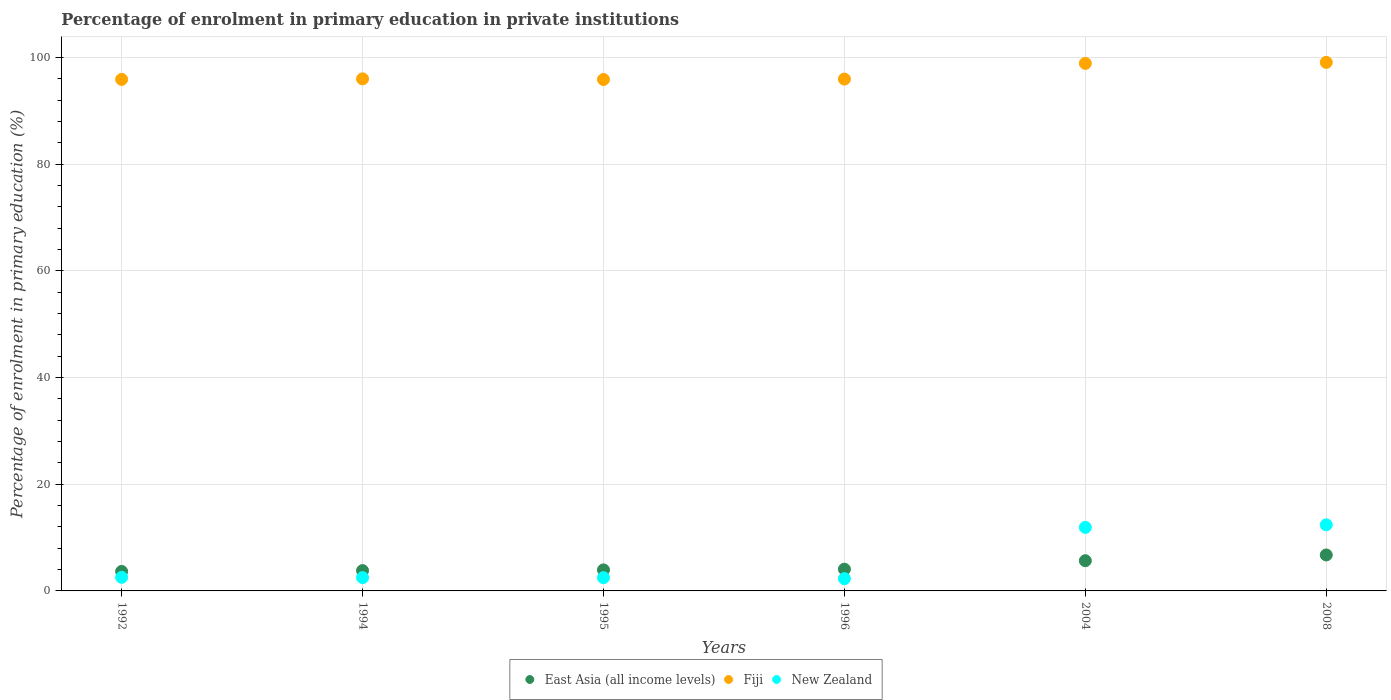How many different coloured dotlines are there?
Make the answer very short. 3. What is the percentage of enrolment in primary education in New Zealand in 1994?
Your answer should be very brief. 2.49. Across all years, what is the maximum percentage of enrolment in primary education in New Zealand?
Offer a very short reply. 12.39. Across all years, what is the minimum percentage of enrolment in primary education in East Asia (all income levels)?
Your answer should be compact. 3.65. In which year was the percentage of enrolment in primary education in Fiji maximum?
Make the answer very short. 2008. What is the total percentage of enrolment in primary education in New Zealand in the graph?
Make the answer very short. 34.14. What is the difference between the percentage of enrolment in primary education in New Zealand in 1994 and that in 1995?
Ensure brevity in your answer.  0.01. What is the difference between the percentage of enrolment in primary education in East Asia (all income levels) in 2004 and the percentage of enrolment in primary education in Fiji in 1996?
Ensure brevity in your answer.  -90.29. What is the average percentage of enrolment in primary education in East Asia (all income levels) per year?
Your response must be concise. 4.65. In the year 1994, what is the difference between the percentage of enrolment in primary education in New Zealand and percentage of enrolment in primary education in Fiji?
Provide a succinct answer. -93.5. In how many years, is the percentage of enrolment in primary education in New Zealand greater than 72 %?
Ensure brevity in your answer.  0. What is the ratio of the percentage of enrolment in primary education in East Asia (all income levels) in 1994 to that in 1995?
Ensure brevity in your answer.  0.97. Is the percentage of enrolment in primary education in Fiji in 2004 less than that in 2008?
Give a very brief answer. Yes. What is the difference between the highest and the second highest percentage of enrolment in primary education in Fiji?
Provide a short and direct response. 0.19. What is the difference between the highest and the lowest percentage of enrolment in primary education in New Zealand?
Give a very brief answer. 10.09. In how many years, is the percentage of enrolment in primary education in Fiji greater than the average percentage of enrolment in primary education in Fiji taken over all years?
Ensure brevity in your answer.  2. Is it the case that in every year, the sum of the percentage of enrolment in primary education in New Zealand and percentage of enrolment in primary education in East Asia (all income levels)  is greater than the percentage of enrolment in primary education in Fiji?
Provide a short and direct response. No. Does the percentage of enrolment in primary education in New Zealand monotonically increase over the years?
Offer a very short reply. No. Is the percentage of enrolment in primary education in Fiji strictly greater than the percentage of enrolment in primary education in New Zealand over the years?
Offer a terse response. Yes. Is the percentage of enrolment in primary education in New Zealand strictly less than the percentage of enrolment in primary education in Fiji over the years?
Ensure brevity in your answer.  Yes. How many dotlines are there?
Provide a succinct answer. 3. Where does the legend appear in the graph?
Keep it short and to the point. Bottom center. How many legend labels are there?
Keep it short and to the point. 3. What is the title of the graph?
Ensure brevity in your answer.  Percentage of enrolment in primary education in private institutions. What is the label or title of the X-axis?
Provide a short and direct response. Years. What is the label or title of the Y-axis?
Ensure brevity in your answer.  Percentage of enrolment in primary education (%). What is the Percentage of enrolment in primary education (%) in East Asia (all income levels) in 1992?
Offer a very short reply. 3.65. What is the Percentage of enrolment in primary education (%) of Fiji in 1992?
Give a very brief answer. 95.9. What is the Percentage of enrolment in primary education (%) of New Zealand in 1992?
Keep it short and to the point. 2.55. What is the Percentage of enrolment in primary education (%) in East Asia (all income levels) in 1994?
Your answer should be compact. 3.81. What is the Percentage of enrolment in primary education (%) in Fiji in 1994?
Offer a very short reply. 96. What is the Percentage of enrolment in primary education (%) in New Zealand in 1994?
Ensure brevity in your answer.  2.49. What is the Percentage of enrolment in primary education (%) in East Asia (all income levels) in 1995?
Your answer should be compact. 3.94. What is the Percentage of enrolment in primary education (%) in Fiji in 1995?
Give a very brief answer. 95.88. What is the Percentage of enrolment in primary education (%) of New Zealand in 1995?
Your response must be concise. 2.48. What is the Percentage of enrolment in primary education (%) of East Asia (all income levels) in 1996?
Your answer should be very brief. 4.07. What is the Percentage of enrolment in primary education (%) of Fiji in 1996?
Give a very brief answer. 95.95. What is the Percentage of enrolment in primary education (%) of New Zealand in 1996?
Make the answer very short. 2.31. What is the Percentage of enrolment in primary education (%) of East Asia (all income levels) in 2004?
Provide a succinct answer. 5.66. What is the Percentage of enrolment in primary education (%) of Fiji in 2004?
Provide a succinct answer. 98.9. What is the Percentage of enrolment in primary education (%) of New Zealand in 2004?
Offer a very short reply. 11.91. What is the Percentage of enrolment in primary education (%) of East Asia (all income levels) in 2008?
Offer a terse response. 6.74. What is the Percentage of enrolment in primary education (%) in Fiji in 2008?
Offer a terse response. 99.08. What is the Percentage of enrolment in primary education (%) of New Zealand in 2008?
Your response must be concise. 12.39. Across all years, what is the maximum Percentage of enrolment in primary education (%) in East Asia (all income levels)?
Offer a very short reply. 6.74. Across all years, what is the maximum Percentage of enrolment in primary education (%) in Fiji?
Give a very brief answer. 99.08. Across all years, what is the maximum Percentage of enrolment in primary education (%) in New Zealand?
Keep it short and to the point. 12.39. Across all years, what is the minimum Percentage of enrolment in primary education (%) of East Asia (all income levels)?
Make the answer very short. 3.65. Across all years, what is the minimum Percentage of enrolment in primary education (%) of Fiji?
Your response must be concise. 95.88. Across all years, what is the minimum Percentage of enrolment in primary education (%) of New Zealand?
Your response must be concise. 2.31. What is the total Percentage of enrolment in primary education (%) of East Asia (all income levels) in the graph?
Your answer should be very brief. 27.88. What is the total Percentage of enrolment in primary education (%) in Fiji in the graph?
Ensure brevity in your answer.  581.7. What is the total Percentage of enrolment in primary education (%) in New Zealand in the graph?
Provide a short and direct response. 34.14. What is the difference between the Percentage of enrolment in primary education (%) in East Asia (all income levels) in 1992 and that in 1994?
Make the answer very short. -0.16. What is the difference between the Percentage of enrolment in primary education (%) of Fiji in 1992 and that in 1994?
Ensure brevity in your answer.  -0.1. What is the difference between the Percentage of enrolment in primary education (%) in New Zealand in 1992 and that in 1994?
Provide a succinct answer. 0.06. What is the difference between the Percentage of enrolment in primary education (%) in East Asia (all income levels) in 1992 and that in 1995?
Give a very brief answer. -0.29. What is the difference between the Percentage of enrolment in primary education (%) in Fiji in 1992 and that in 1995?
Provide a succinct answer. 0.02. What is the difference between the Percentage of enrolment in primary education (%) of New Zealand in 1992 and that in 1995?
Provide a succinct answer. 0.06. What is the difference between the Percentage of enrolment in primary education (%) in East Asia (all income levels) in 1992 and that in 1996?
Ensure brevity in your answer.  -0.42. What is the difference between the Percentage of enrolment in primary education (%) of Fiji in 1992 and that in 1996?
Keep it short and to the point. -0.06. What is the difference between the Percentage of enrolment in primary education (%) in New Zealand in 1992 and that in 1996?
Provide a succinct answer. 0.24. What is the difference between the Percentage of enrolment in primary education (%) in East Asia (all income levels) in 1992 and that in 2004?
Ensure brevity in your answer.  -2.01. What is the difference between the Percentage of enrolment in primary education (%) in Fiji in 1992 and that in 2004?
Make the answer very short. -3. What is the difference between the Percentage of enrolment in primary education (%) in New Zealand in 1992 and that in 2004?
Offer a terse response. -9.36. What is the difference between the Percentage of enrolment in primary education (%) of East Asia (all income levels) in 1992 and that in 2008?
Your response must be concise. -3.09. What is the difference between the Percentage of enrolment in primary education (%) in Fiji in 1992 and that in 2008?
Provide a succinct answer. -3.19. What is the difference between the Percentage of enrolment in primary education (%) in New Zealand in 1992 and that in 2008?
Offer a terse response. -9.85. What is the difference between the Percentage of enrolment in primary education (%) in East Asia (all income levels) in 1994 and that in 1995?
Offer a terse response. -0.13. What is the difference between the Percentage of enrolment in primary education (%) in Fiji in 1994 and that in 1995?
Provide a succinct answer. 0.12. What is the difference between the Percentage of enrolment in primary education (%) in New Zealand in 1994 and that in 1995?
Make the answer very short. 0.01. What is the difference between the Percentage of enrolment in primary education (%) of East Asia (all income levels) in 1994 and that in 1996?
Make the answer very short. -0.26. What is the difference between the Percentage of enrolment in primary education (%) in Fiji in 1994 and that in 1996?
Your answer should be compact. 0.04. What is the difference between the Percentage of enrolment in primary education (%) in New Zealand in 1994 and that in 1996?
Provide a short and direct response. 0.19. What is the difference between the Percentage of enrolment in primary education (%) of East Asia (all income levels) in 1994 and that in 2004?
Provide a succinct answer. -1.85. What is the difference between the Percentage of enrolment in primary education (%) in Fiji in 1994 and that in 2004?
Offer a very short reply. -2.9. What is the difference between the Percentage of enrolment in primary education (%) of New Zealand in 1994 and that in 2004?
Make the answer very short. -9.42. What is the difference between the Percentage of enrolment in primary education (%) in East Asia (all income levels) in 1994 and that in 2008?
Provide a succinct answer. -2.93. What is the difference between the Percentage of enrolment in primary education (%) in Fiji in 1994 and that in 2008?
Provide a succinct answer. -3.09. What is the difference between the Percentage of enrolment in primary education (%) in New Zealand in 1994 and that in 2008?
Keep it short and to the point. -9.9. What is the difference between the Percentage of enrolment in primary education (%) in East Asia (all income levels) in 1995 and that in 1996?
Offer a terse response. -0.13. What is the difference between the Percentage of enrolment in primary education (%) in Fiji in 1995 and that in 1996?
Your answer should be compact. -0.08. What is the difference between the Percentage of enrolment in primary education (%) of New Zealand in 1995 and that in 1996?
Provide a succinct answer. 0.18. What is the difference between the Percentage of enrolment in primary education (%) in East Asia (all income levels) in 1995 and that in 2004?
Offer a very short reply. -1.72. What is the difference between the Percentage of enrolment in primary education (%) of Fiji in 1995 and that in 2004?
Your response must be concise. -3.02. What is the difference between the Percentage of enrolment in primary education (%) in New Zealand in 1995 and that in 2004?
Offer a very short reply. -9.43. What is the difference between the Percentage of enrolment in primary education (%) of East Asia (all income levels) in 1995 and that in 2008?
Ensure brevity in your answer.  -2.8. What is the difference between the Percentage of enrolment in primary education (%) of Fiji in 1995 and that in 2008?
Provide a succinct answer. -3.21. What is the difference between the Percentage of enrolment in primary education (%) of New Zealand in 1995 and that in 2008?
Ensure brevity in your answer.  -9.91. What is the difference between the Percentage of enrolment in primary education (%) in East Asia (all income levels) in 1996 and that in 2004?
Offer a terse response. -1.59. What is the difference between the Percentage of enrolment in primary education (%) in Fiji in 1996 and that in 2004?
Make the answer very short. -2.94. What is the difference between the Percentage of enrolment in primary education (%) in New Zealand in 1996 and that in 2004?
Provide a succinct answer. -9.6. What is the difference between the Percentage of enrolment in primary education (%) in East Asia (all income levels) in 1996 and that in 2008?
Make the answer very short. -2.67. What is the difference between the Percentage of enrolment in primary education (%) of Fiji in 1996 and that in 2008?
Provide a succinct answer. -3.13. What is the difference between the Percentage of enrolment in primary education (%) of New Zealand in 1996 and that in 2008?
Your answer should be compact. -10.09. What is the difference between the Percentage of enrolment in primary education (%) in East Asia (all income levels) in 2004 and that in 2008?
Give a very brief answer. -1.08. What is the difference between the Percentage of enrolment in primary education (%) in Fiji in 2004 and that in 2008?
Provide a succinct answer. -0.19. What is the difference between the Percentage of enrolment in primary education (%) in New Zealand in 2004 and that in 2008?
Offer a terse response. -0.48. What is the difference between the Percentage of enrolment in primary education (%) of East Asia (all income levels) in 1992 and the Percentage of enrolment in primary education (%) of Fiji in 1994?
Provide a short and direct response. -92.34. What is the difference between the Percentage of enrolment in primary education (%) of East Asia (all income levels) in 1992 and the Percentage of enrolment in primary education (%) of New Zealand in 1994?
Provide a short and direct response. 1.16. What is the difference between the Percentage of enrolment in primary education (%) in Fiji in 1992 and the Percentage of enrolment in primary education (%) in New Zealand in 1994?
Provide a short and direct response. 93.4. What is the difference between the Percentage of enrolment in primary education (%) of East Asia (all income levels) in 1992 and the Percentage of enrolment in primary education (%) of Fiji in 1995?
Offer a terse response. -92.22. What is the difference between the Percentage of enrolment in primary education (%) of East Asia (all income levels) in 1992 and the Percentage of enrolment in primary education (%) of New Zealand in 1995?
Give a very brief answer. 1.17. What is the difference between the Percentage of enrolment in primary education (%) of Fiji in 1992 and the Percentage of enrolment in primary education (%) of New Zealand in 1995?
Ensure brevity in your answer.  93.41. What is the difference between the Percentage of enrolment in primary education (%) in East Asia (all income levels) in 1992 and the Percentage of enrolment in primary education (%) in Fiji in 1996?
Your answer should be very brief. -92.3. What is the difference between the Percentage of enrolment in primary education (%) of East Asia (all income levels) in 1992 and the Percentage of enrolment in primary education (%) of New Zealand in 1996?
Your response must be concise. 1.35. What is the difference between the Percentage of enrolment in primary education (%) in Fiji in 1992 and the Percentage of enrolment in primary education (%) in New Zealand in 1996?
Your answer should be compact. 93.59. What is the difference between the Percentage of enrolment in primary education (%) in East Asia (all income levels) in 1992 and the Percentage of enrolment in primary education (%) in Fiji in 2004?
Provide a succinct answer. -95.24. What is the difference between the Percentage of enrolment in primary education (%) of East Asia (all income levels) in 1992 and the Percentage of enrolment in primary education (%) of New Zealand in 2004?
Ensure brevity in your answer.  -8.26. What is the difference between the Percentage of enrolment in primary education (%) of Fiji in 1992 and the Percentage of enrolment in primary education (%) of New Zealand in 2004?
Your answer should be very brief. 83.99. What is the difference between the Percentage of enrolment in primary education (%) of East Asia (all income levels) in 1992 and the Percentage of enrolment in primary education (%) of Fiji in 2008?
Provide a short and direct response. -95.43. What is the difference between the Percentage of enrolment in primary education (%) in East Asia (all income levels) in 1992 and the Percentage of enrolment in primary education (%) in New Zealand in 2008?
Offer a very short reply. -8.74. What is the difference between the Percentage of enrolment in primary education (%) of Fiji in 1992 and the Percentage of enrolment in primary education (%) of New Zealand in 2008?
Your response must be concise. 83.5. What is the difference between the Percentage of enrolment in primary education (%) in East Asia (all income levels) in 1994 and the Percentage of enrolment in primary education (%) in Fiji in 1995?
Give a very brief answer. -92.07. What is the difference between the Percentage of enrolment in primary education (%) of East Asia (all income levels) in 1994 and the Percentage of enrolment in primary education (%) of New Zealand in 1995?
Offer a terse response. 1.32. What is the difference between the Percentage of enrolment in primary education (%) of Fiji in 1994 and the Percentage of enrolment in primary education (%) of New Zealand in 1995?
Offer a very short reply. 93.51. What is the difference between the Percentage of enrolment in primary education (%) in East Asia (all income levels) in 1994 and the Percentage of enrolment in primary education (%) in Fiji in 1996?
Your answer should be very brief. -92.15. What is the difference between the Percentage of enrolment in primary education (%) in East Asia (all income levels) in 1994 and the Percentage of enrolment in primary education (%) in New Zealand in 1996?
Ensure brevity in your answer.  1.5. What is the difference between the Percentage of enrolment in primary education (%) of Fiji in 1994 and the Percentage of enrolment in primary education (%) of New Zealand in 1996?
Make the answer very short. 93.69. What is the difference between the Percentage of enrolment in primary education (%) in East Asia (all income levels) in 1994 and the Percentage of enrolment in primary education (%) in Fiji in 2004?
Offer a very short reply. -95.09. What is the difference between the Percentage of enrolment in primary education (%) of East Asia (all income levels) in 1994 and the Percentage of enrolment in primary education (%) of New Zealand in 2004?
Ensure brevity in your answer.  -8.1. What is the difference between the Percentage of enrolment in primary education (%) of Fiji in 1994 and the Percentage of enrolment in primary education (%) of New Zealand in 2004?
Offer a terse response. 84.09. What is the difference between the Percentage of enrolment in primary education (%) in East Asia (all income levels) in 1994 and the Percentage of enrolment in primary education (%) in Fiji in 2008?
Your response must be concise. -95.27. What is the difference between the Percentage of enrolment in primary education (%) of East Asia (all income levels) in 1994 and the Percentage of enrolment in primary education (%) of New Zealand in 2008?
Offer a terse response. -8.59. What is the difference between the Percentage of enrolment in primary education (%) in Fiji in 1994 and the Percentage of enrolment in primary education (%) in New Zealand in 2008?
Provide a succinct answer. 83.6. What is the difference between the Percentage of enrolment in primary education (%) in East Asia (all income levels) in 1995 and the Percentage of enrolment in primary education (%) in Fiji in 1996?
Keep it short and to the point. -92.01. What is the difference between the Percentage of enrolment in primary education (%) of East Asia (all income levels) in 1995 and the Percentage of enrolment in primary education (%) of New Zealand in 1996?
Make the answer very short. 1.64. What is the difference between the Percentage of enrolment in primary education (%) in Fiji in 1995 and the Percentage of enrolment in primary education (%) in New Zealand in 1996?
Offer a terse response. 93.57. What is the difference between the Percentage of enrolment in primary education (%) of East Asia (all income levels) in 1995 and the Percentage of enrolment in primary education (%) of Fiji in 2004?
Ensure brevity in your answer.  -94.95. What is the difference between the Percentage of enrolment in primary education (%) in East Asia (all income levels) in 1995 and the Percentage of enrolment in primary education (%) in New Zealand in 2004?
Provide a succinct answer. -7.97. What is the difference between the Percentage of enrolment in primary education (%) in Fiji in 1995 and the Percentage of enrolment in primary education (%) in New Zealand in 2004?
Ensure brevity in your answer.  83.97. What is the difference between the Percentage of enrolment in primary education (%) of East Asia (all income levels) in 1995 and the Percentage of enrolment in primary education (%) of Fiji in 2008?
Offer a terse response. -95.14. What is the difference between the Percentage of enrolment in primary education (%) of East Asia (all income levels) in 1995 and the Percentage of enrolment in primary education (%) of New Zealand in 2008?
Offer a terse response. -8.45. What is the difference between the Percentage of enrolment in primary education (%) of Fiji in 1995 and the Percentage of enrolment in primary education (%) of New Zealand in 2008?
Your answer should be very brief. 83.48. What is the difference between the Percentage of enrolment in primary education (%) in East Asia (all income levels) in 1996 and the Percentage of enrolment in primary education (%) in Fiji in 2004?
Keep it short and to the point. -94.82. What is the difference between the Percentage of enrolment in primary education (%) of East Asia (all income levels) in 1996 and the Percentage of enrolment in primary education (%) of New Zealand in 2004?
Make the answer very short. -7.84. What is the difference between the Percentage of enrolment in primary education (%) of Fiji in 1996 and the Percentage of enrolment in primary education (%) of New Zealand in 2004?
Make the answer very short. 84.04. What is the difference between the Percentage of enrolment in primary education (%) of East Asia (all income levels) in 1996 and the Percentage of enrolment in primary education (%) of Fiji in 2008?
Provide a succinct answer. -95.01. What is the difference between the Percentage of enrolment in primary education (%) in East Asia (all income levels) in 1996 and the Percentage of enrolment in primary education (%) in New Zealand in 2008?
Ensure brevity in your answer.  -8.32. What is the difference between the Percentage of enrolment in primary education (%) of Fiji in 1996 and the Percentage of enrolment in primary education (%) of New Zealand in 2008?
Keep it short and to the point. 83.56. What is the difference between the Percentage of enrolment in primary education (%) of East Asia (all income levels) in 2004 and the Percentage of enrolment in primary education (%) of Fiji in 2008?
Offer a terse response. -93.42. What is the difference between the Percentage of enrolment in primary education (%) in East Asia (all income levels) in 2004 and the Percentage of enrolment in primary education (%) in New Zealand in 2008?
Your response must be concise. -6.73. What is the difference between the Percentage of enrolment in primary education (%) of Fiji in 2004 and the Percentage of enrolment in primary education (%) of New Zealand in 2008?
Your answer should be very brief. 86.5. What is the average Percentage of enrolment in primary education (%) in East Asia (all income levels) per year?
Offer a terse response. 4.65. What is the average Percentage of enrolment in primary education (%) in Fiji per year?
Make the answer very short. 96.95. What is the average Percentage of enrolment in primary education (%) of New Zealand per year?
Offer a very short reply. 5.69. In the year 1992, what is the difference between the Percentage of enrolment in primary education (%) of East Asia (all income levels) and Percentage of enrolment in primary education (%) of Fiji?
Offer a very short reply. -92.24. In the year 1992, what is the difference between the Percentage of enrolment in primary education (%) in East Asia (all income levels) and Percentage of enrolment in primary education (%) in New Zealand?
Keep it short and to the point. 1.1. In the year 1992, what is the difference between the Percentage of enrolment in primary education (%) in Fiji and Percentage of enrolment in primary education (%) in New Zealand?
Provide a short and direct response. 93.35. In the year 1994, what is the difference between the Percentage of enrolment in primary education (%) in East Asia (all income levels) and Percentage of enrolment in primary education (%) in Fiji?
Keep it short and to the point. -92.19. In the year 1994, what is the difference between the Percentage of enrolment in primary education (%) of East Asia (all income levels) and Percentage of enrolment in primary education (%) of New Zealand?
Your response must be concise. 1.31. In the year 1994, what is the difference between the Percentage of enrolment in primary education (%) in Fiji and Percentage of enrolment in primary education (%) in New Zealand?
Make the answer very short. 93.5. In the year 1995, what is the difference between the Percentage of enrolment in primary education (%) in East Asia (all income levels) and Percentage of enrolment in primary education (%) in Fiji?
Give a very brief answer. -91.93. In the year 1995, what is the difference between the Percentage of enrolment in primary education (%) of East Asia (all income levels) and Percentage of enrolment in primary education (%) of New Zealand?
Your response must be concise. 1.46. In the year 1995, what is the difference between the Percentage of enrolment in primary education (%) in Fiji and Percentage of enrolment in primary education (%) in New Zealand?
Your answer should be compact. 93.39. In the year 1996, what is the difference between the Percentage of enrolment in primary education (%) of East Asia (all income levels) and Percentage of enrolment in primary education (%) of Fiji?
Your answer should be very brief. -91.88. In the year 1996, what is the difference between the Percentage of enrolment in primary education (%) of East Asia (all income levels) and Percentage of enrolment in primary education (%) of New Zealand?
Make the answer very short. 1.77. In the year 1996, what is the difference between the Percentage of enrolment in primary education (%) of Fiji and Percentage of enrolment in primary education (%) of New Zealand?
Provide a short and direct response. 93.65. In the year 2004, what is the difference between the Percentage of enrolment in primary education (%) of East Asia (all income levels) and Percentage of enrolment in primary education (%) of Fiji?
Offer a very short reply. -93.23. In the year 2004, what is the difference between the Percentage of enrolment in primary education (%) of East Asia (all income levels) and Percentage of enrolment in primary education (%) of New Zealand?
Offer a very short reply. -6.25. In the year 2004, what is the difference between the Percentage of enrolment in primary education (%) in Fiji and Percentage of enrolment in primary education (%) in New Zealand?
Give a very brief answer. 86.99. In the year 2008, what is the difference between the Percentage of enrolment in primary education (%) in East Asia (all income levels) and Percentage of enrolment in primary education (%) in Fiji?
Your response must be concise. -92.34. In the year 2008, what is the difference between the Percentage of enrolment in primary education (%) in East Asia (all income levels) and Percentage of enrolment in primary education (%) in New Zealand?
Make the answer very short. -5.65. In the year 2008, what is the difference between the Percentage of enrolment in primary education (%) in Fiji and Percentage of enrolment in primary education (%) in New Zealand?
Your response must be concise. 86.69. What is the ratio of the Percentage of enrolment in primary education (%) in East Asia (all income levels) in 1992 to that in 1994?
Provide a succinct answer. 0.96. What is the ratio of the Percentage of enrolment in primary education (%) in New Zealand in 1992 to that in 1994?
Your answer should be compact. 1.02. What is the ratio of the Percentage of enrolment in primary education (%) in East Asia (all income levels) in 1992 to that in 1995?
Offer a very short reply. 0.93. What is the ratio of the Percentage of enrolment in primary education (%) in New Zealand in 1992 to that in 1995?
Ensure brevity in your answer.  1.03. What is the ratio of the Percentage of enrolment in primary education (%) in East Asia (all income levels) in 1992 to that in 1996?
Your answer should be very brief. 0.9. What is the ratio of the Percentage of enrolment in primary education (%) in Fiji in 1992 to that in 1996?
Offer a terse response. 1. What is the ratio of the Percentage of enrolment in primary education (%) in New Zealand in 1992 to that in 1996?
Offer a terse response. 1.1. What is the ratio of the Percentage of enrolment in primary education (%) in East Asia (all income levels) in 1992 to that in 2004?
Provide a short and direct response. 0.65. What is the ratio of the Percentage of enrolment in primary education (%) of Fiji in 1992 to that in 2004?
Make the answer very short. 0.97. What is the ratio of the Percentage of enrolment in primary education (%) of New Zealand in 1992 to that in 2004?
Ensure brevity in your answer.  0.21. What is the ratio of the Percentage of enrolment in primary education (%) of East Asia (all income levels) in 1992 to that in 2008?
Give a very brief answer. 0.54. What is the ratio of the Percentage of enrolment in primary education (%) in Fiji in 1992 to that in 2008?
Provide a short and direct response. 0.97. What is the ratio of the Percentage of enrolment in primary education (%) in New Zealand in 1992 to that in 2008?
Your response must be concise. 0.21. What is the ratio of the Percentage of enrolment in primary education (%) of East Asia (all income levels) in 1994 to that in 1995?
Ensure brevity in your answer.  0.97. What is the ratio of the Percentage of enrolment in primary education (%) in East Asia (all income levels) in 1994 to that in 1996?
Give a very brief answer. 0.94. What is the ratio of the Percentage of enrolment in primary education (%) in Fiji in 1994 to that in 1996?
Offer a terse response. 1. What is the ratio of the Percentage of enrolment in primary education (%) of New Zealand in 1994 to that in 1996?
Keep it short and to the point. 1.08. What is the ratio of the Percentage of enrolment in primary education (%) of East Asia (all income levels) in 1994 to that in 2004?
Provide a short and direct response. 0.67. What is the ratio of the Percentage of enrolment in primary education (%) in Fiji in 1994 to that in 2004?
Keep it short and to the point. 0.97. What is the ratio of the Percentage of enrolment in primary education (%) in New Zealand in 1994 to that in 2004?
Offer a terse response. 0.21. What is the ratio of the Percentage of enrolment in primary education (%) in East Asia (all income levels) in 1994 to that in 2008?
Provide a succinct answer. 0.56. What is the ratio of the Percentage of enrolment in primary education (%) in Fiji in 1994 to that in 2008?
Make the answer very short. 0.97. What is the ratio of the Percentage of enrolment in primary education (%) in New Zealand in 1994 to that in 2008?
Offer a terse response. 0.2. What is the ratio of the Percentage of enrolment in primary education (%) in East Asia (all income levels) in 1995 to that in 1996?
Make the answer very short. 0.97. What is the ratio of the Percentage of enrolment in primary education (%) in Fiji in 1995 to that in 1996?
Provide a short and direct response. 1. What is the ratio of the Percentage of enrolment in primary education (%) of New Zealand in 1995 to that in 1996?
Give a very brief answer. 1.08. What is the ratio of the Percentage of enrolment in primary education (%) of East Asia (all income levels) in 1995 to that in 2004?
Make the answer very short. 0.7. What is the ratio of the Percentage of enrolment in primary education (%) of Fiji in 1995 to that in 2004?
Make the answer very short. 0.97. What is the ratio of the Percentage of enrolment in primary education (%) in New Zealand in 1995 to that in 2004?
Your answer should be compact. 0.21. What is the ratio of the Percentage of enrolment in primary education (%) in East Asia (all income levels) in 1995 to that in 2008?
Your answer should be very brief. 0.58. What is the ratio of the Percentage of enrolment in primary education (%) in Fiji in 1995 to that in 2008?
Offer a very short reply. 0.97. What is the ratio of the Percentage of enrolment in primary education (%) of New Zealand in 1995 to that in 2008?
Make the answer very short. 0.2. What is the ratio of the Percentage of enrolment in primary education (%) of East Asia (all income levels) in 1996 to that in 2004?
Provide a short and direct response. 0.72. What is the ratio of the Percentage of enrolment in primary education (%) of Fiji in 1996 to that in 2004?
Offer a terse response. 0.97. What is the ratio of the Percentage of enrolment in primary education (%) in New Zealand in 1996 to that in 2004?
Your response must be concise. 0.19. What is the ratio of the Percentage of enrolment in primary education (%) in East Asia (all income levels) in 1996 to that in 2008?
Offer a very short reply. 0.6. What is the ratio of the Percentage of enrolment in primary education (%) in Fiji in 1996 to that in 2008?
Your answer should be compact. 0.97. What is the ratio of the Percentage of enrolment in primary education (%) in New Zealand in 1996 to that in 2008?
Your answer should be very brief. 0.19. What is the ratio of the Percentage of enrolment in primary education (%) in East Asia (all income levels) in 2004 to that in 2008?
Offer a terse response. 0.84. What is the ratio of the Percentage of enrolment in primary education (%) of Fiji in 2004 to that in 2008?
Your answer should be compact. 1. What is the ratio of the Percentage of enrolment in primary education (%) in New Zealand in 2004 to that in 2008?
Provide a succinct answer. 0.96. What is the difference between the highest and the second highest Percentage of enrolment in primary education (%) of East Asia (all income levels)?
Your answer should be compact. 1.08. What is the difference between the highest and the second highest Percentage of enrolment in primary education (%) of Fiji?
Your answer should be very brief. 0.19. What is the difference between the highest and the second highest Percentage of enrolment in primary education (%) of New Zealand?
Provide a short and direct response. 0.48. What is the difference between the highest and the lowest Percentage of enrolment in primary education (%) in East Asia (all income levels)?
Give a very brief answer. 3.09. What is the difference between the highest and the lowest Percentage of enrolment in primary education (%) in Fiji?
Make the answer very short. 3.21. What is the difference between the highest and the lowest Percentage of enrolment in primary education (%) in New Zealand?
Offer a very short reply. 10.09. 